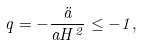Convert formula to latex. <formula><loc_0><loc_0><loc_500><loc_500>q = - \frac { \ddot { a } } { a H ^ { 2 } } \leq - 1 ,</formula> 